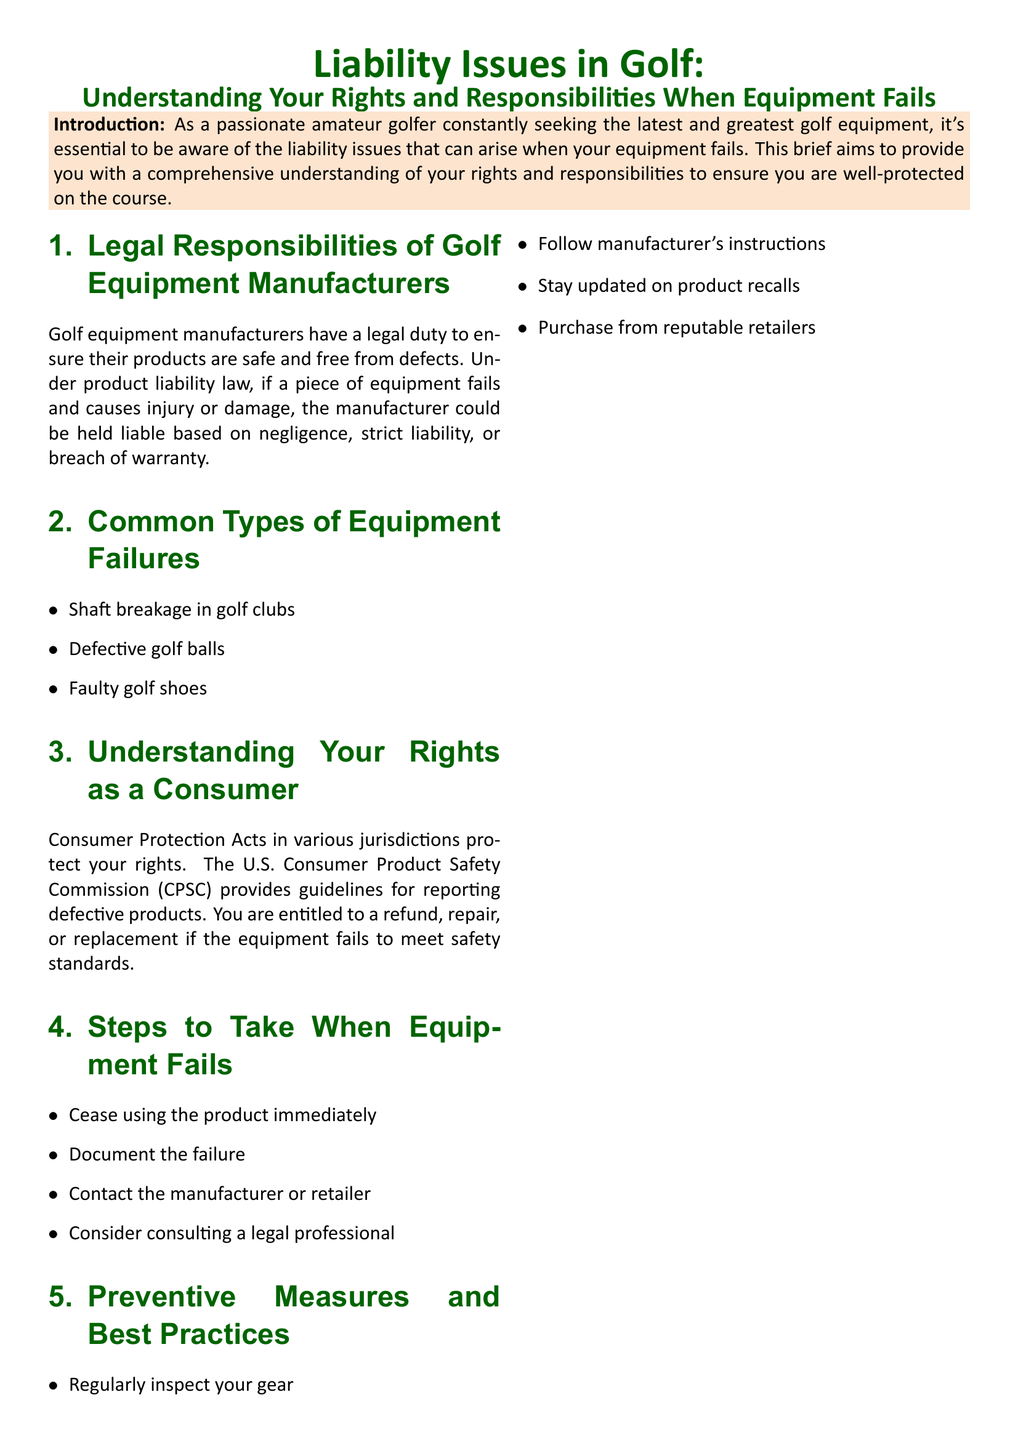What is the title of the document? The title is presented prominently at the beginning and outlines the overall topic of the brief.
Answer: Liability Issues in Golf: Understanding Your Rights and Responsibilities When Equipment Fails What color is used for the section headings? The color used for section headings is specified as part of the styling of the document.
Answer: Golfgreen Name one type of equipment failure mentioned. The document lists specific failures in the "Common Types of Equipment Failures" section.
Answer: Shaft breakage in golf clubs What should you do immediately when your equipment fails? This action is recommended in the "Steps to Take When Equipment Fails" section of the brief.
Answer: Cease using the product immediately Which organization provides guidelines for reporting defective products? The brief references an organization that is focused on consumer product safety in the U.S.
Answer: U.S. Consumer Product Safety Commission (CPSC) What is a preventive measure suggested in the document? The document includes specific best practices to avoid equipment issues.
Answer: Regularly inspect your gear How many common types of equipment failures are listed in the document? The number of types of equipment failures mentioned is listed in the corresponding section.
Answer: Three What is the main purpose of the document? The purpose is outlined in the introduction, reflecting the aim of the brief.
Answer: To provide you with a comprehensive understanding of your rights and responsibilities What legal duty do golf equipment manufacturers have? The manufacturer's responsibility is described in the context of product liability law in the brief.
Answer: Ensure their products are safe and free from defects 